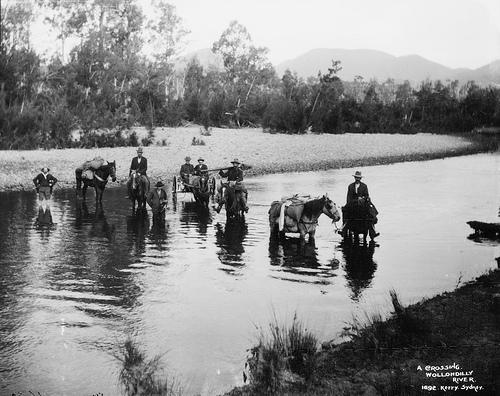How many horses are shown?
Give a very brief answer. 6. Is this an old picture?
Give a very brief answer. Yes. Are the people in a lake?
Give a very brief answer. Yes. 